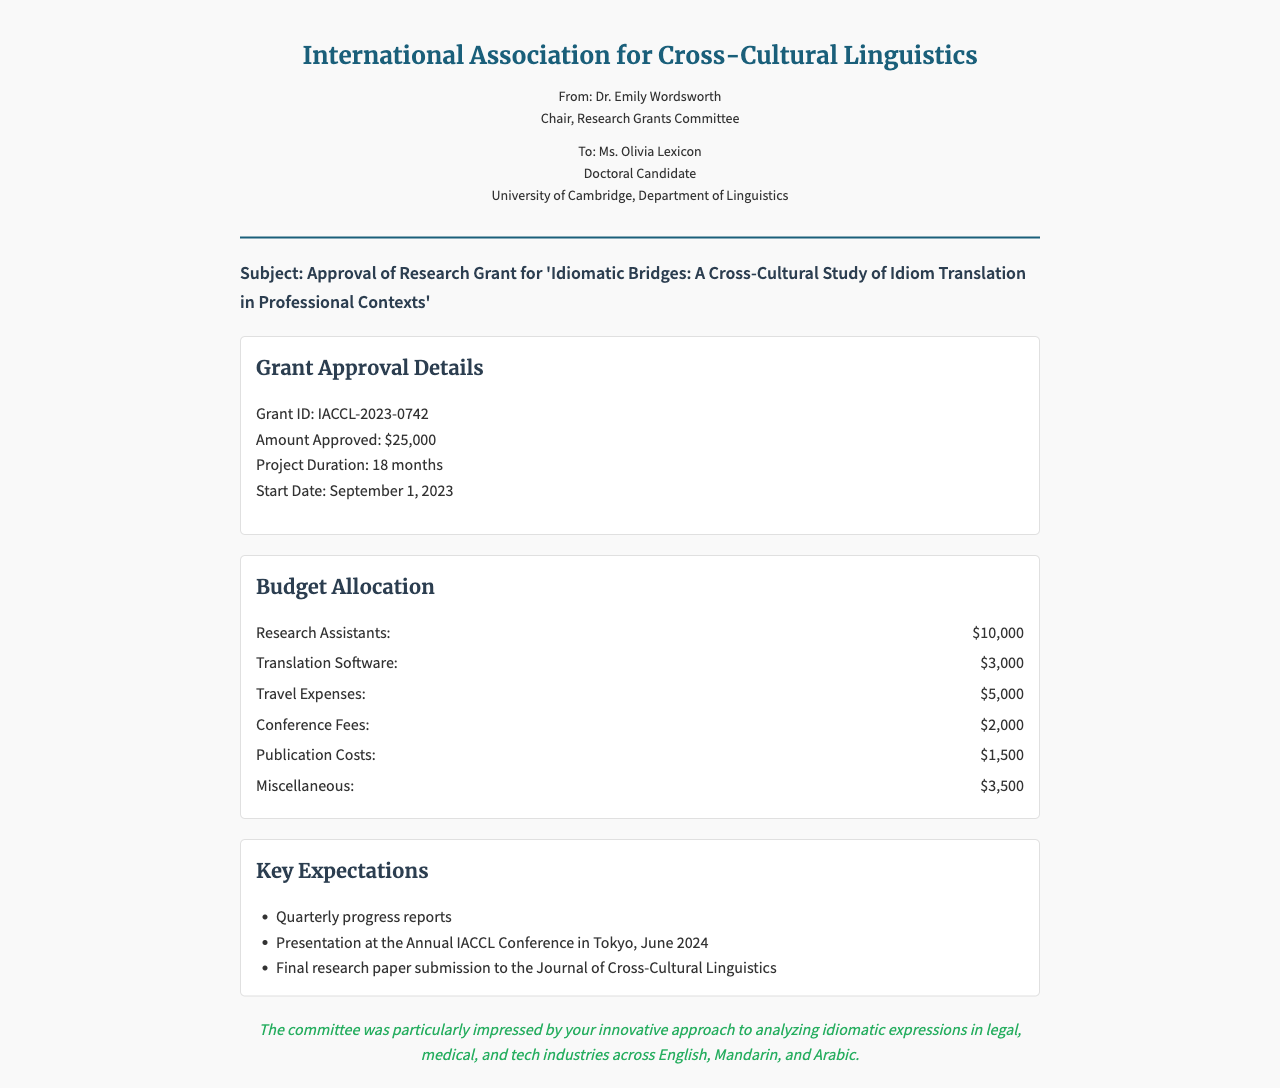What is the grant ID? The grant ID is stated in the document as IACCL-2023-0742.
Answer: IACCL-2023-0742 What is the amount approved for the grant? The document specifies the amount approved for the grant as $25,000.
Answer: $25,000 How long is the project duration? The project duration is indicated in the document as 18 months.
Answer: 18 months When is the start date of the project? The start date of the project is mentioned as September 1, 2023.
Answer: September 1, 2023 What is the total budget for research assistants? The budget for research assistants is highlighted in the document as $10,000.
Answer: $10,000 What are the expected travel expenses? The expected travel expenses are outlined as $5,000 in the budget section.
Answer: $5,000 What is one of the key expectations for the grant? The document mentions "Quarterly progress reports" as one of the key expectations.
Answer: Quarterly progress reports What conference will the recipient present at? The recipient is expected to present at the Annual IACCL Conference in Tokyo.
Answer: Annual IACCL Conference in Tokyo Who is the sender of the fax? The sender of the fax is Dr. Emily Wordsworth, as stated in the sender info section.
Answer: Dr. Emily Wordsworth What is noted about the recipient's approach? The committee was particularly impressed by the recipient's innovative approach to analyzing idiomatic expressions.
Answer: innovative approach 